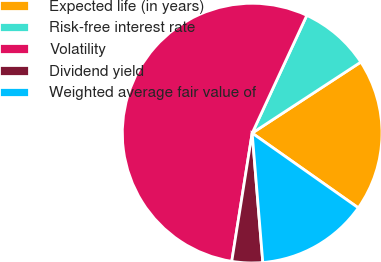Convert chart. <chart><loc_0><loc_0><loc_500><loc_500><pie_chart><fcel>Expected life (in years)<fcel>Risk-free interest rate<fcel>Volatility<fcel>Dividend yield<fcel>Weighted average fair value of<nl><fcel>18.98%<fcel>8.87%<fcel>54.4%<fcel>3.82%<fcel>13.93%<nl></chart> 